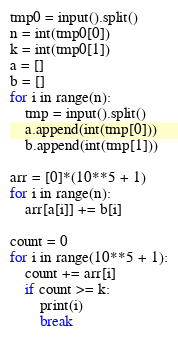Convert code to text. <code><loc_0><loc_0><loc_500><loc_500><_Python_>tmp0 = input().split()
n = int(tmp0[0])
k = int(tmp0[1])
a = []
b = []
for i in range(n):
    tmp = input().split()
    a.append(int(tmp[0]))
    b.append(int(tmp[1]))

arr = [0]*(10**5 + 1)
for i in range(n):
    arr[a[i]] += b[i]

count = 0
for i in range(10**5 + 1):
    count += arr[i]
    if count >= k:
        print(i)
        break
</code> 